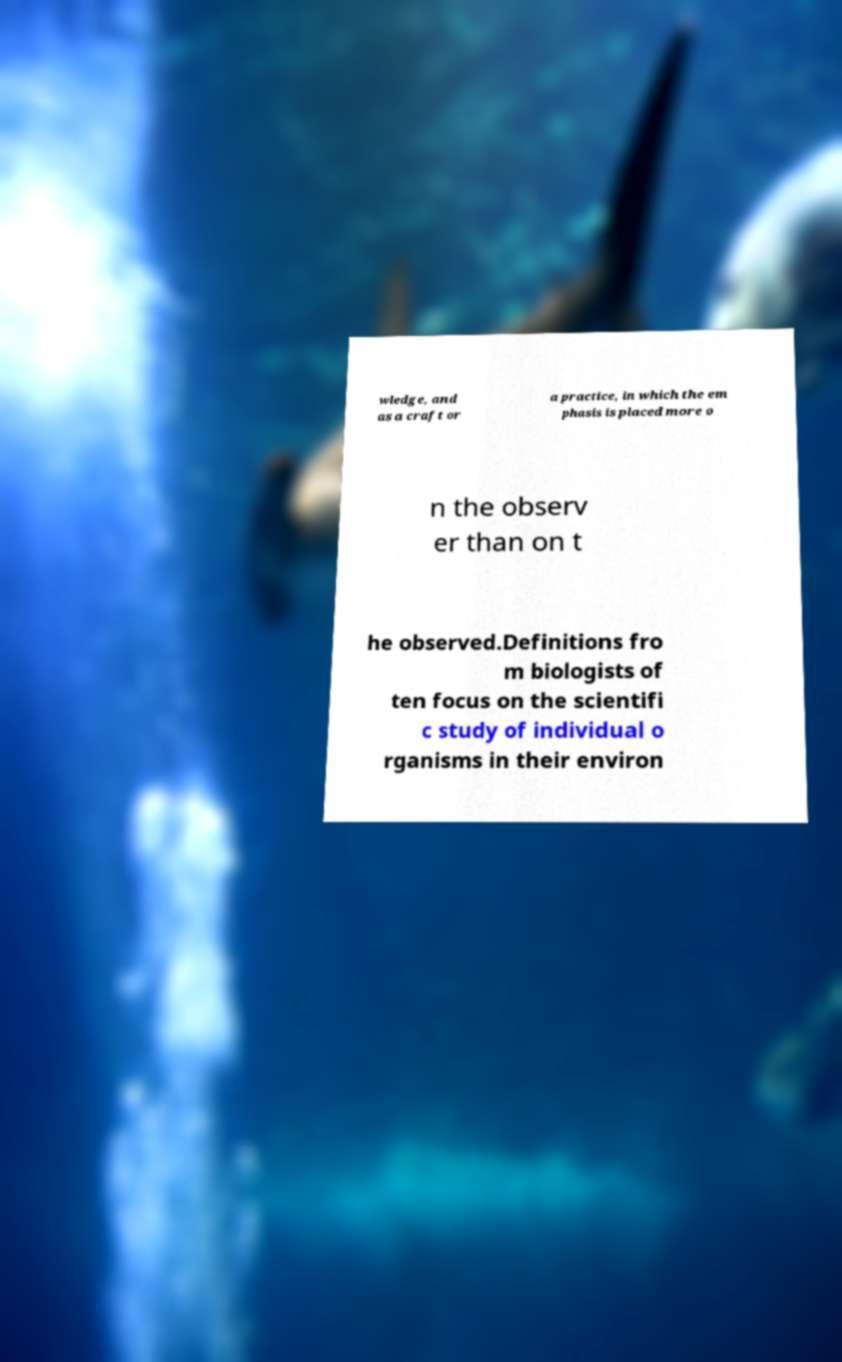For documentation purposes, I need the text within this image transcribed. Could you provide that? wledge, and as a craft or a practice, in which the em phasis is placed more o n the observ er than on t he observed.Definitions fro m biologists of ten focus on the scientifi c study of individual o rganisms in their environ 